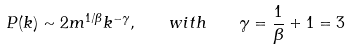Convert formula to latex. <formula><loc_0><loc_0><loc_500><loc_500>P ( k ) \sim 2 m ^ { 1 / \beta } k ^ { - \gamma } , \quad w i t h \quad \gamma = \frac { 1 } { \beta } + 1 = 3</formula> 